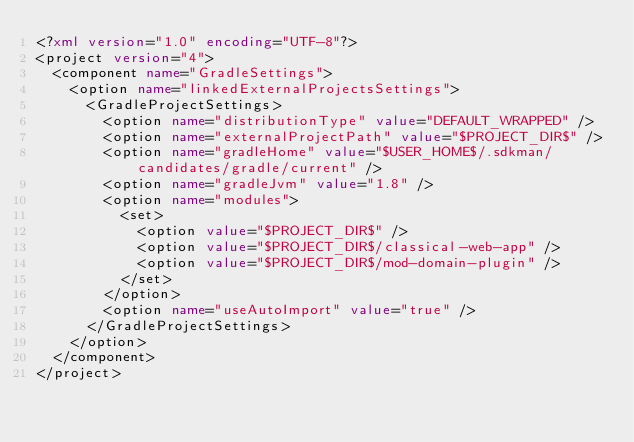<code> <loc_0><loc_0><loc_500><loc_500><_XML_><?xml version="1.0" encoding="UTF-8"?>
<project version="4">
  <component name="GradleSettings">
    <option name="linkedExternalProjectsSettings">
      <GradleProjectSettings>
        <option name="distributionType" value="DEFAULT_WRAPPED" />
        <option name="externalProjectPath" value="$PROJECT_DIR$" />
        <option name="gradleHome" value="$USER_HOME$/.sdkman/candidates/gradle/current" />
        <option name="gradleJvm" value="1.8" />
        <option name="modules">
          <set>
            <option value="$PROJECT_DIR$" />
            <option value="$PROJECT_DIR$/classical-web-app" />
            <option value="$PROJECT_DIR$/mod-domain-plugin" />
          </set>
        </option>
        <option name="useAutoImport" value="true" />
      </GradleProjectSettings>
    </option>
  </component>
</project></code> 